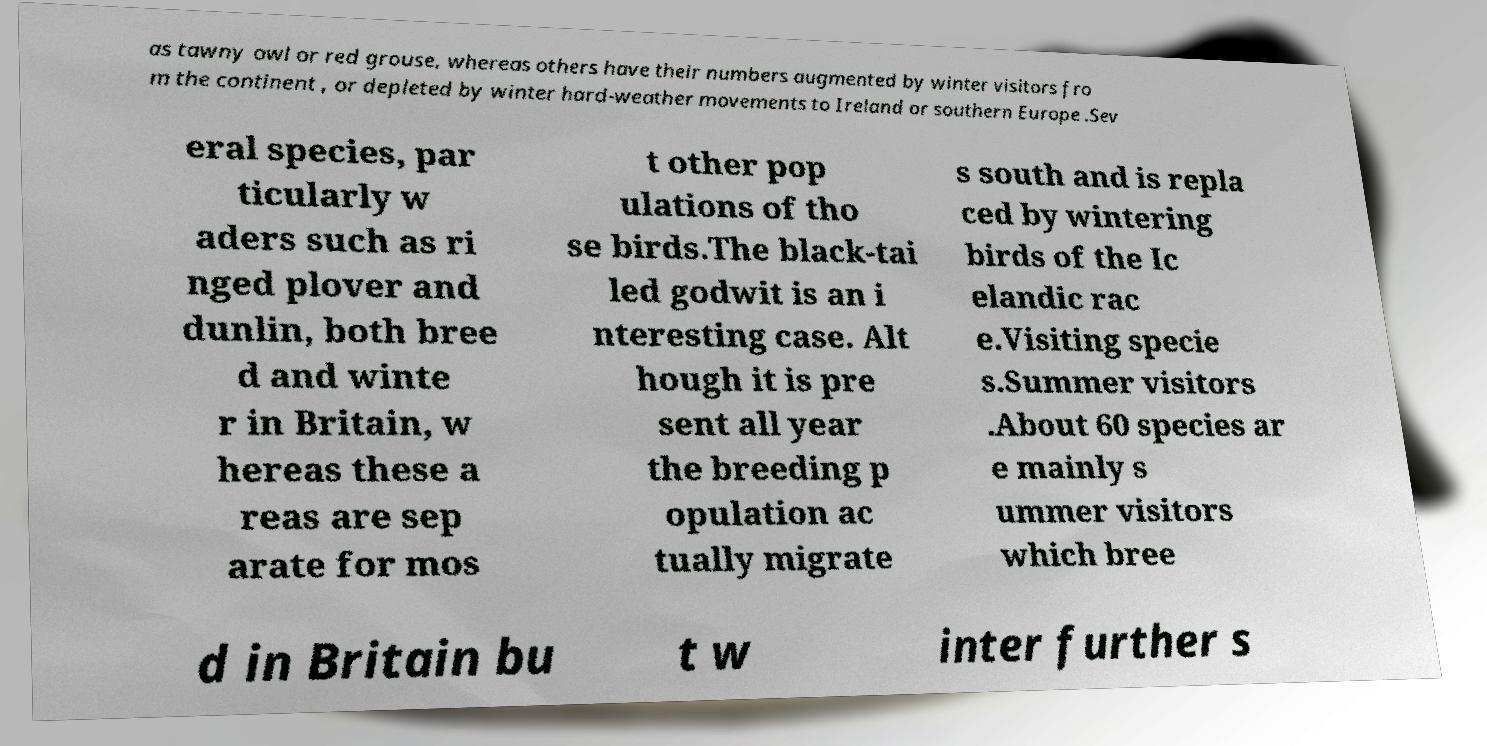I need the written content from this picture converted into text. Can you do that? as tawny owl or red grouse, whereas others have their numbers augmented by winter visitors fro m the continent , or depleted by winter hard-weather movements to Ireland or southern Europe .Sev eral species, par ticularly w aders such as ri nged plover and dunlin, both bree d and winte r in Britain, w hereas these a reas are sep arate for mos t other pop ulations of tho se birds.The black-tai led godwit is an i nteresting case. Alt hough it is pre sent all year the breeding p opulation ac tually migrate s south and is repla ced by wintering birds of the Ic elandic rac e.Visiting specie s.Summer visitors .About 60 species ar e mainly s ummer visitors which bree d in Britain bu t w inter further s 